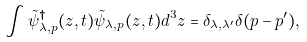Convert formula to latex. <formula><loc_0><loc_0><loc_500><loc_500>\int \tilde { \psi } _ { \lambda , p } ^ { \dag } ( z , t ) \tilde { \psi } _ { \lambda , p } ( z , t ) d ^ { 3 } z = \delta _ { \lambda , \lambda ^ { \prime } } \delta ( p - p ^ { \prime } ) ,</formula> 